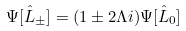<formula> <loc_0><loc_0><loc_500><loc_500>\Psi [ \hat { L } _ { \pm } ] = ( 1 \pm 2 \Lambda i ) \Psi [ \hat { L } _ { 0 } ]</formula> 